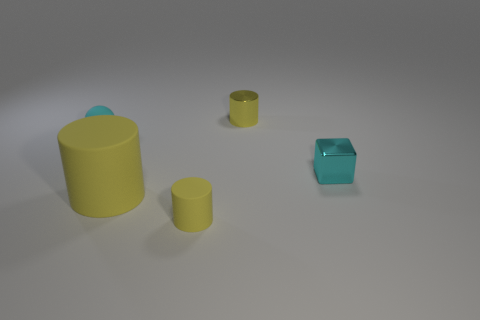Subtract all large yellow matte cylinders. How many cylinders are left? 2 How many yellow cylinders must be subtracted to get 1 yellow cylinders? 2 Subtract 1 cylinders. How many cylinders are left? 2 Subtract all gray balls. Subtract all blue cubes. How many balls are left? 1 Subtract all big brown metal cylinders. Subtract all yellow metal cylinders. How many objects are left? 4 Add 1 tiny cylinders. How many tiny cylinders are left? 3 Add 1 large yellow matte cylinders. How many large yellow matte cylinders exist? 2 Add 2 small green rubber things. How many objects exist? 7 Subtract 0 gray balls. How many objects are left? 5 Subtract all blocks. How many objects are left? 4 